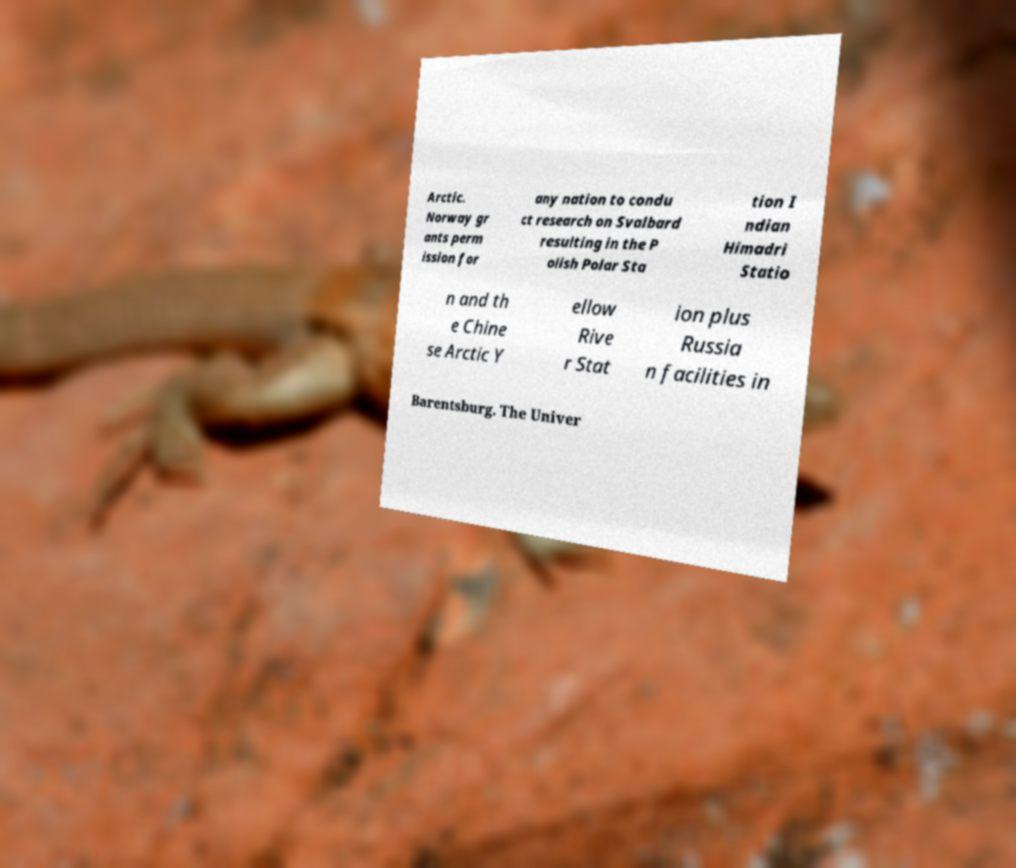For documentation purposes, I need the text within this image transcribed. Could you provide that? Arctic. Norway gr ants perm ission for any nation to condu ct research on Svalbard resulting in the P olish Polar Sta tion I ndian Himadri Statio n and th e Chine se Arctic Y ellow Rive r Stat ion plus Russia n facilities in Barentsburg. The Univer 